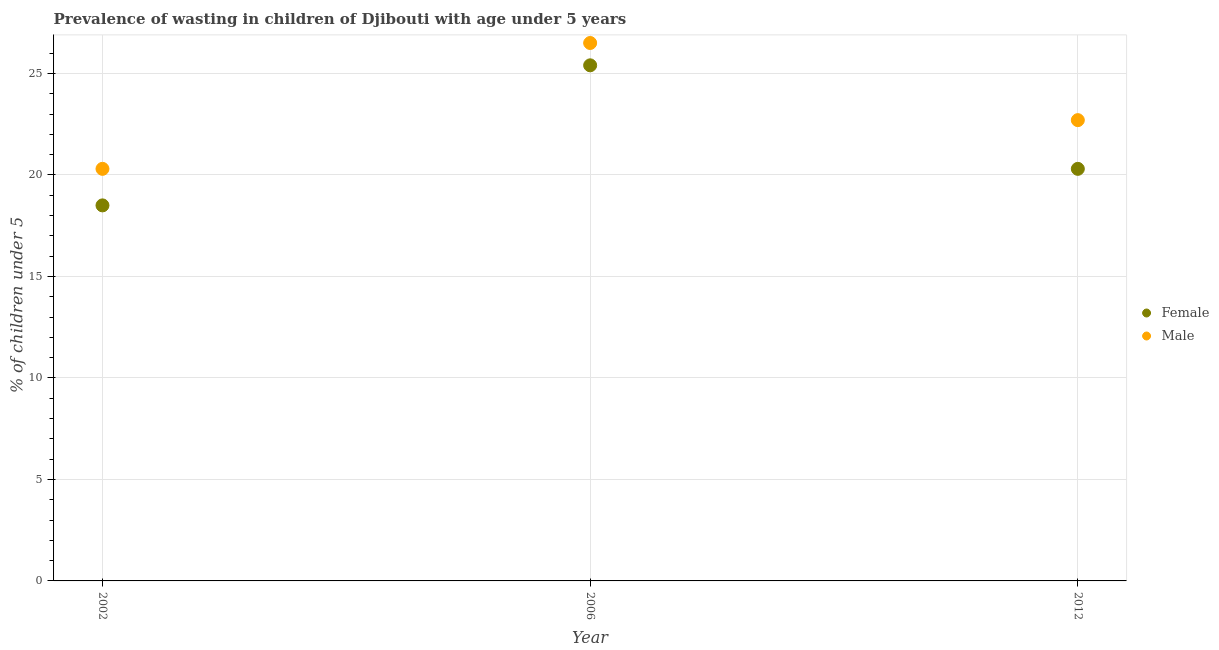How many different coloured dotlines are there?
Provide a short and direct response. 2. Is the number of dotlines equal to the number of legend labels?
Ensure brevity in your answer.  Yes. What is the percentage of undernourished female children in 2006?
Make the answer very short. 25.4. Across all years, what is the maximum percentage of undernourished female children?
Provide a succinct answer. 25.4. Across all years, what is the minimum percentage of undernourished male children?
Your answer should be very brief. 20.3. In which year was the percentage of undernourished female children maximum?
Make the answer very short. 2006. What is the total percentage of undernourished male children in the graph?
Make the answer very short. 69.5. What is the difference between the percentage of undernourished female children in 2002 and that in 2012?
Offer a very short reply. -1.8. What is the average percentage of undernourished female children per year?
Keep it short and to the point. 21.4. In the year 2002, what is the difference between the percentage of undernourished female children and percentage of undernourished male children?
Offer a terse response. -1.8. In how many years, is the percentage of undernourished male children greater than 14 %?
Provide a short and direct response. 3. What is the ratio of the percentage of undernourished female children in 2006 to that in 2012?
Your response must be concise. 1.25. Is the difference between the percentage of undernourished female children in 2002 and 2006 greater than the difference between the percentage of undernourished male children in 2002 and 2006?
Make the answer very short. No. What is the difference between the highest and the second highest percentage of undernourished male children?
Your response must be concise. 3.8. What is the difference between the highest and the lowest percentage of undernourished male children?
Your response must be concise. 6.2. In how many years, is the percentage of undernourished female children greater than the average percentage of undernourished female children taken over all years?
Make the answer very short. 1. Does the percentage of undernourished male children monotonically increase over the years?
Your answer should be compact. No. How many dotlines are there?
Ensure brevity in your answer.  2. How many years are there in the graph?
Ensure brevity in your answer.  3. What is the difference between two consecutive major ticks on the Y-axis?
Make the answer very short. 5. Does the graph contain any zero values?
Ensure brevity in your answer.  No. Does the graph contain grids?
Offer a very short reply. Yes. How many legend labels are there?
Give a very brief answer. 2. What is the title of the graph?
Your answer should be very brief. Prevalence of wasting in children of Djibouti with age under 5 years. Does "Pregnant women" appear as one of the legend labels in the graph?
Provide a succinct answer. No. What is the label or title of the Y-axis?
Your response must be concise.  % of children under 5. What is the  % of children under 5 in Female in 2002?
Your answer should be very brief. 18.5. What is the  % of children under 5 of Male in 2002?
Your answer should be very brief. 20.3. What is the  % of children under 5 in Female in 2006?
Keep it short and to the point. 25.4. What is the  % of children under 5 in Female in 2012?
Offer a terse response. 20.3. What is the  % of children under 5 of Male in 2012?
Give a very brief answer. 22.7. Across all years, what is the maximum  % of children under 5 in Female?
Your answer should be compact. 25.4. Across all years, what is the maximum  % of children under 5 of Male?
Make the answer very short. 26.5. Across all years, what is the minimum  % of children under 5 in Male?
Offer a terse response. 20.3. What is the total  % of children under 5 of Female in the graph?
Keep it short and to the point. 64.2. What is the total  % of children under 5 of Male in the graph?
Ensure brevity in your answer.  69.5. What is the difference between the  % of children under 5 in Female in 2002 and that in 2012?
Your response must be concise. -1.8. What is the difference between the  % of children under 5 of Male in 2002 and that in 2012?
Make the answer very short. -2.4. What is the difference between the  % of children under 5 of Male in 2006 and that in 2012?
Your answer should be compact. 3.8. What is the difference between the  % of children under 5 of Female in 2002 and the  % of children under 5 of Male in 2012?
Your response must be concise. -4.2. What is the difference between the  % of children under 5 of Female in 2006 and the  % of children under 5 of Male in 2012?
Offer a very short reply. 2.7. What is the average  % of children under 5 in Female per year?
Your answer should be very brief. 21.4. What is the average  % of children under 5 of Male per year?
Provide a succinct answer. 23.17. In the year 2002, what is the difference between the  % of children under 5 in Female and  % of children under 5 in Male?
Offer a very short reply. -1.8. In the year 2006, what is the difference between the  % of children under 5 in Female and  % of children under 5 in Male?
Keep it short and to the point. -1.1. What is the ratio of the  % of children under 5 in Female in 2002 to that in 2006?
Your answer should be compact. 0.73. What is the ratio of the  % of children under 5 of Male in 2002 to that in 2006?
Offer a very short reply. 0.77. What is the ratio of the  % of children under 5 of Female in 2002 to that in 2012?
Your response must be concise. 0.91. What is the ratio of the  % of children under 5 in Male in 2002 to that in 2012?
Make the answer very short. 0.89. What is the ratio of the  % of children under 5 in Female in 2006 to that in 2012?
Offer a terse response. 1.25. What is the ratio of the  % of children under 5 in Male in 2006 to that in 2012?
Provide a short and direct response. 1.17. What is the difference between the highest and the second highest  % of children under 5 of Male?
Keep it short and to the point. 3.8. What is the difference between the highest and the lowest  % of children under 5 in Female?
Provide a succinct answer. 6.9. What is the difference between the highest and the lowest  % of children under 5 in Male?
Ensure brevity in your answer.  6.2. 